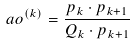<formula> <loc_0><loc_0><loc_500><loc_500>\ a o ^ { ( k ) } = \frac { p _ { k } \cdot p _ { k + 1 } } { Q _ { k } \cdot p _ { k + 1 } }</formula> 